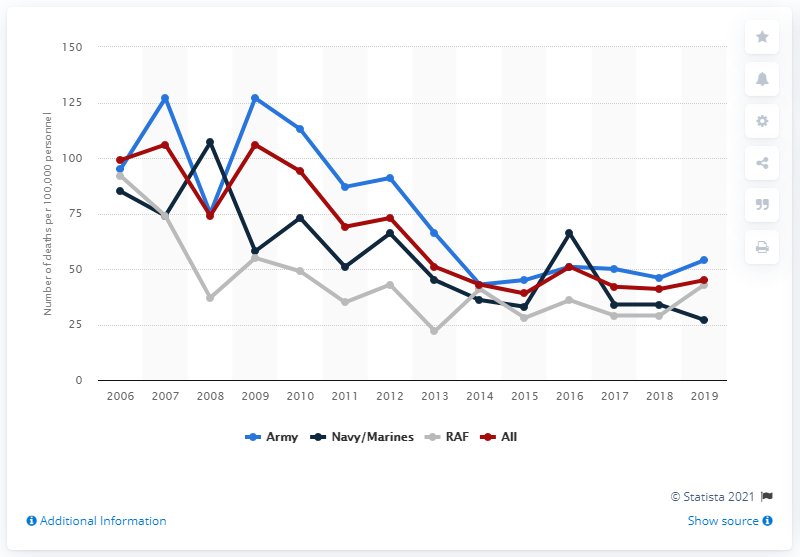Indicate a few pertinent items in this graphic. In 2019, the mortality rate among all branches of the armed forces was 45%. 